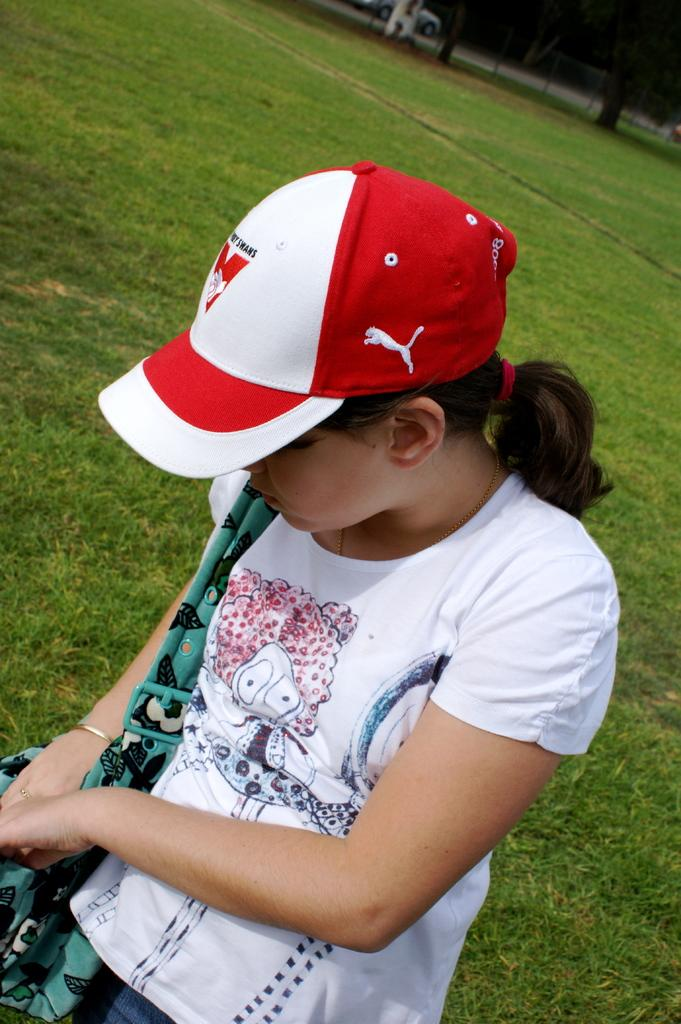Who or what is present in the image? There is a person in the image. Can you describe the person's attire? The person is wearing a cap. What object can be seen on the ground in the image? There is a handbag on the ground in the image. What type of cloth is being used to measure the cent in the image? There is no cloth or cent present in the image. Is there a spring visible in the image? No, there is no spring visible in the image. 